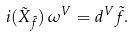<formula> <loc_0><loc_0><loc_500><loc_500>i ( \tilde { X } _ { \tilde { f } } ) \, \omega ^ { V } = d ^ { V } \tilde { f } .</formula> 